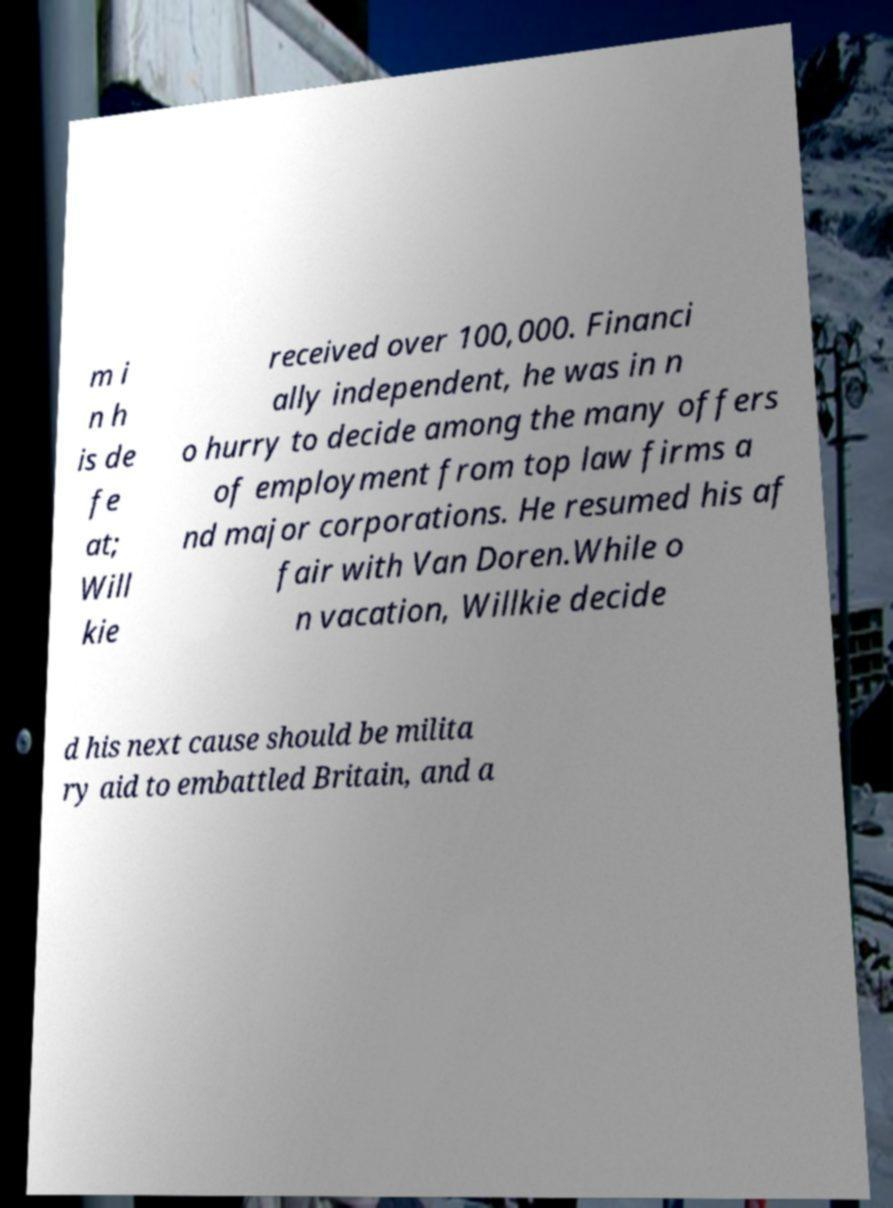Please identify and transcribe the text found in this image. m i n h is de fe at; Will kie received over 100,000. Financi ally independent, he was in n o hurry to decide among the many offers of employment from top law firms a nd major corporations. He resumed his af fair with Van Doren.While o n vacation, Willkie decide d his next cause should be milita ry aid to embattled Britain, and a 